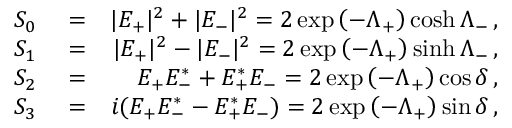<formula> <loc_0><loc_0><loc_500><loc_500>\begin{array} { r l r } { S _ { 0 } } & = } & { | E _ { + } | ^ { 2 } + | E _ { - } | ^ { 2 } = 2 \exp \left ( - \Lambda _ { + } \right ) \cosh \Lambda _ { - } \, , } \\ { S _ { 1 } } & = } & { | E _ { + } | ^ { 2 } - | E _ { - } | ^ { 2 } = 2 \exp \left ( - \Lambda _ { + } \right ) \sinh \Lambda _ { - } \, , } \\ { S _ { 2 } } & = } & { E _ { + } E _ { - } ^ { * } + E _ { + } ^ { * } E _ { - } = 2 \exp \left ( - \Lambda _ { + } \right ) \cos \delta \, , } \\ { S _ { 3 } } & = } & { i ( E _ { + } E _ { - } ^ { * } - E _ { + } ^ { * } E _ { - } ) = 2 \exp \left ( - \Lambda _ { + } \right ) \sin \delta \, , } \end{array}</formula> 